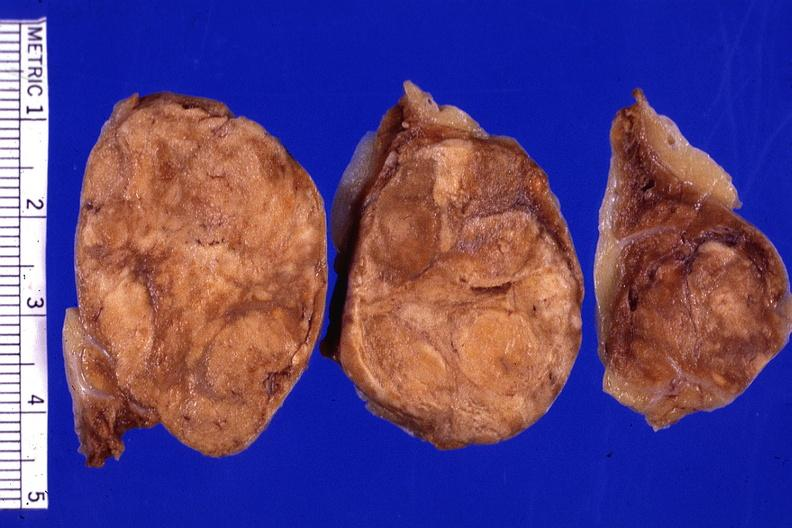s adrenal present?
Answer the question using a single word or phrase. Yes 